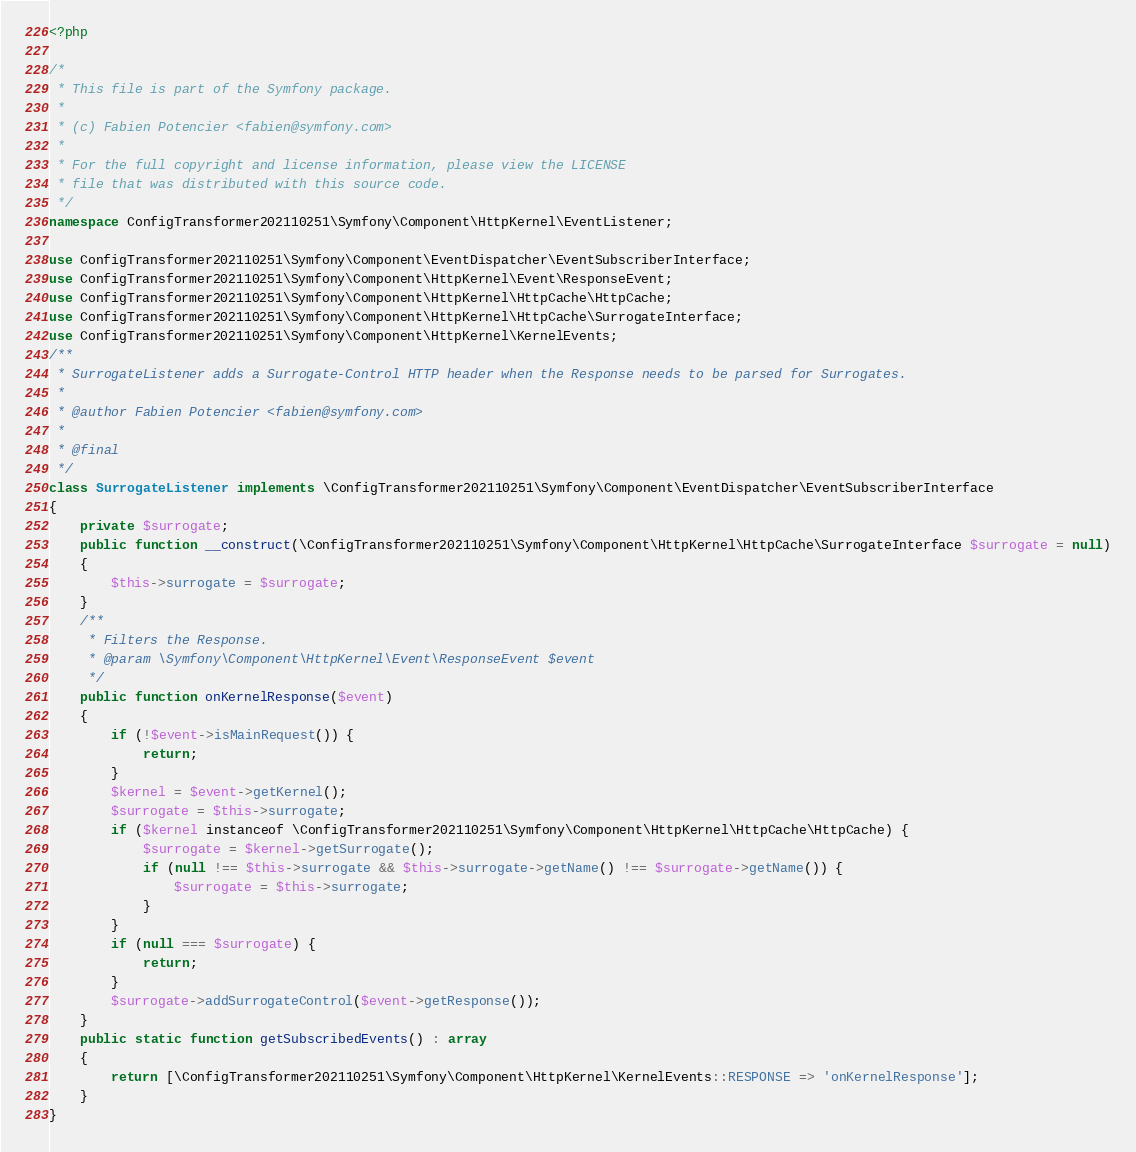<code> <loc_0><loc_0><loc_500><loc_500><_PHP_><?php

/*
 * This file is part of the Symfony package.
 *
 * (c) Fabien Potencier <fabien@symfony.com>
 *
 * For the full copyright and license information, please view the LICENSE
 * file that was distributed with this source code.
 */
namespace ConfigTransformer202110251\Symfony\Component\HttpKernel\EventListener;

use ConfigTransformer202110251\Symfony\Component\EventDispatcher\EventSubscriberInterface;
use ConfigTransformer202110251\Symfony\Component\HttpKernel\Event\ResponseEvent;
use ConfigTransformer202110251\Symfony\Component\HttpKernel\HttpCache\HttpCache;
use ConfigTransformer202110251\Symfony\Component\HttpKernel\HttpCache\SurrogateInterface;
use ConfigTransformer202110251\Symfony\Component\HttpKernel\KernelEvents;
/**
 * SurrogateListener adds a Surrogate-Control HTTP header when the Response needs to be parsed for Surrogates.
 *
 * @author Fabien Potencier <fabien@symfony.com>
 *
 * @final
 */
class SurrogateListener implements \ConfigTransformer202110251\Symfony\Component\EventDispatcher\EventSubscriberInterface
{
    private $surrogate;
    public function __construct(\ConfigTransformer202110251\Symfony\Component\HttpKernel\HttpCache\SurrogateInterface $surrogate = null)
    {
        $this->surrogate = $surrogate;
    }
    /**
     * Filters the Response.
     * @param \Symfony\Component\HttpKernel\Event\ResponseEvent $event
     */
    public function onKernelResponse($event)
    {
        if (!$event->isMainRequest()) {
            return;
        }
        $kernel = $event->getKernel();
        $surrogate = $this->surrogate;
        if ($kernel instanceof \ConfigTransformer202110251\Symfony\Component\HttpKernel\HttpCache\HttpCache) {
            $surrogate = $kernel->getSurrogate();
            if (null !== $this->surrogate && $this->surrogate->getName() !== $surrogate->getName()) {
                $surrogate = $this->surrogate;
            }
        }
        if (null === $surrogate) {
            return;
        }
        $surrogate->addSurrogateControl($event->getResponse());
    }
    public static function getSubscribedEvents() : array
    {
        return [\ConfigTransformer202110251\Symfony\Component\HttpKernel\KernelEvents::RESPONSE => 'onKernelResponse'];
    }
}
</code> 